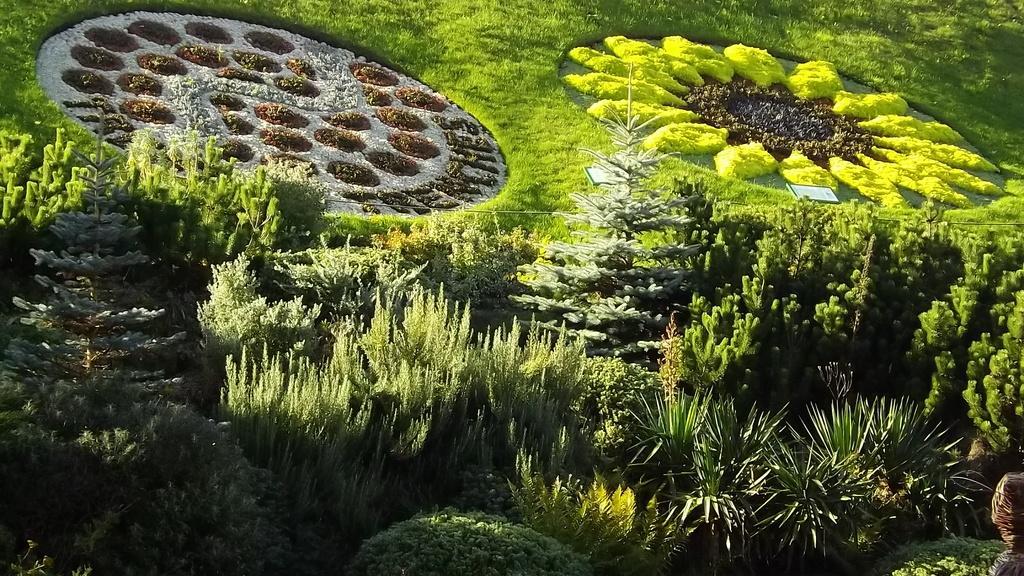Could you give a brief overview of what you see in this image? In this picture we can see few plants and garden arts, at the right bottom of the image we can see a person. 